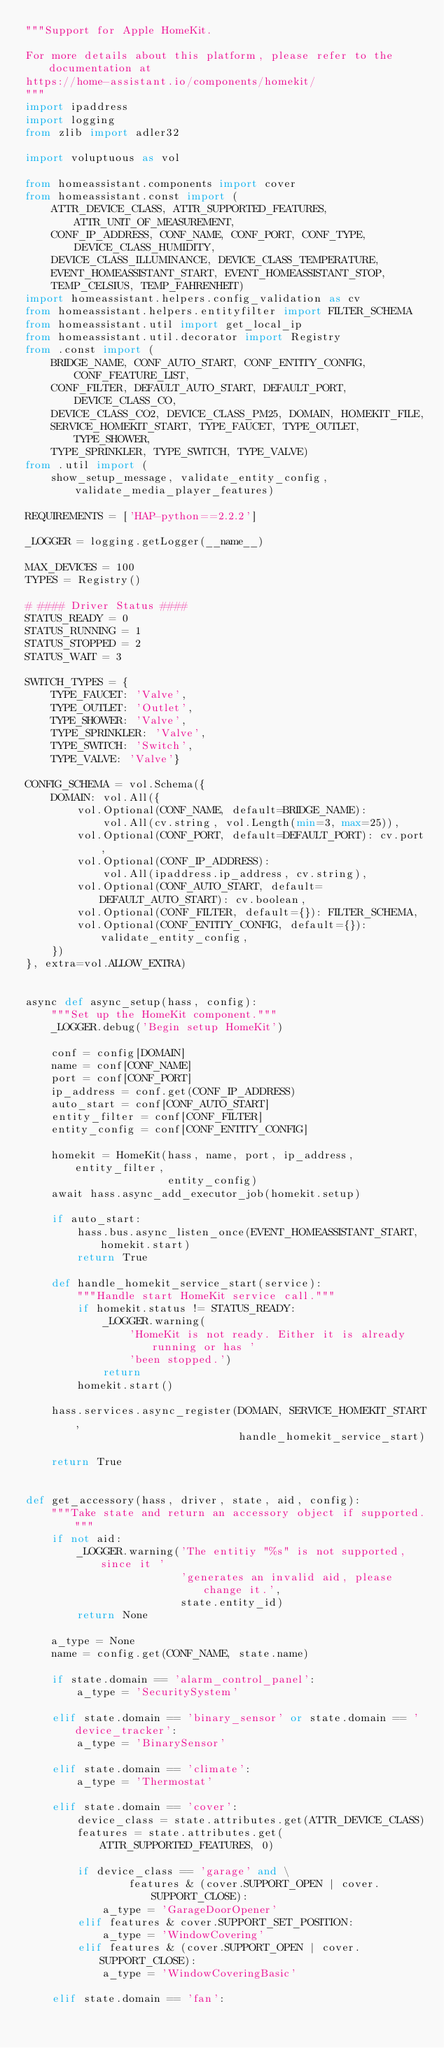Convert code to text. <code><loc_0><loc_0><loc_500><loc_500><_Python_>"""Support for Apple HomeKit.

For more details about this platform, please refer to the documentation at
https://home-assistant.io/components/homekit/
"""
import ipaddress
import logging
from zlib import adler32

import voluptuous as vol

from homeassistant.components import cover
from homeassistant.const import (
    ATTR_DEVICE_CLASS, ATTR_SUPPORTED_FEATURES, ATTR_UNIT_OF_MEASUREMENT,
    CONF_IP_ADDRESS, CONF_NAME, CONF_PORT, CONF_TYPE, DEVICE_CLASS_HUMIDITY,
    DEVICE_CLASS_ILLUMINANCE, DEVICE_CLASS_TEMPERATURE,
    EVENT_HOMEASSISTANT_START, EVENT_HOMEASSISTANT_STOP,
    TEMP_CELSIUS, TEMP_FAHRENHEIT)
import homeassistant.helpers.config_validation as cv
from homeassistant.helpers.entityfilter import FILTER_SCHEMA
from homeassistant.util import get_local_ip
from homeassistant.util.decorator import Registry
from .const import (
    BRIDGE_NAME, CONF_AUTO_START, CONF_ENTITY_CONFIG, CONF_FEATURE_LIST,
    CONF_FILTER, DEFAULT_AUTO_START, DEFAULT_PORT, DEVICE_CLASS_CO,
    DEVICE_CLASS_CO2, DEVICE_CLASS_PM25, DOMAIN, HOMEKIT_FILE,
    SERVICE_HOMEKIT_START, TYPE_FAUCET, TYPE_OUTLET, TYPE_SHOWER,
    TYPE_SPRINKLER, TYPE_SWITCH, TYPE_VALVE)
from .util import (
    show_setup_message, validate_entity_config, validate_media_player_features)

REQUIREMENTS = ['HAP-python==2.2.2']

_LOGGER = logging.getLogger(__name__)

MAX_DEVICES = 100
TYPES = Registry()

# #### Driver Status ####
STATUS_READY = 0
STATUS_RUNNING = 1
STATUS_STOPPED = 2
STATUS_WAIT = 3

SWITCH_TYPES = {
    TYPE_FAUCET: 'Valve',
    TYPE_OUTLET: 'Outlet',
    TYPE_SHOWER: 'Valve',
    TYPE_SPRINKLER: 'Valve',
    TYPE_SWITCH: 'Switch',
    TYPE_VALVE: 'Valve'}

CONFIG_SCHEMA = vol.Schema({
    DOMAIN: vol.All({
        vol.Optional(CONF_NAME, default=BRIDGE_NAME):
            vol.All(cv.string, vol.Length(min=3, max=25)),
        vol.Optional(CONF_PORT, default=DEFAULT_PORT): cv.port,
        vol.Optional(CONF_IP_ADDRESS):
            vol.All(ipaddress.ip_address, cv.string),
        vol.Optional(CONF_AUTO_START, default=DEFAULT_AUTO_START): cv.boolean,
        vol.Optional(CONF_FILTER, default={}): FILTER_SCHEMA,
        vol.Optional(CONF_ENTITY_CONFIG, default={}): validate_entity_config,
    })
}, extra=vol.ALLOW_EXTRA)


async def async_setup(hass, config):
    """Set up the HomeKit component."""
    _LOGGER.debug('Begin setup HomeKit')

    conf = config[DOMAIN]
    name = conf[CONF_NAME]
    port = conf[CONF_PORT]
    ip_address = conf.get(CONF_IP_ADDRESS)
    auto_start = conf[CONF_AUTO_START]
    entity_filter = conf[CONF_FILTER]
    entity_config = conf[CONF_ENTITY_CONFIG]

    homekit = HomeKit(hass, name, port, ip_address, entity_filter,
                      entity_config)
    await hass.async_add_executor_job(homekit.setup)

    if auto_start:
        hass.bus.async_listen_once(EVENT_HOMEASSISTANT_START, homekit.start)
        return True

    def handle_homekit_service_start(service):
        """Handle start HomeKit service call."""
        if homekit.status != STATUS_READY:
            _LOGGER.warning(
                'HomeKit is not ready. Either it is already running or has '
                'been stopped.')
            return
        homekit.start()

    hass.services.async_register(DOMAIN, SERVICE_HOMEKIT_START,
                                 handle_homekit_service_start)

    return True


def get_accessory(hass, driver, state, aid, config):
    """Take state and return an accessory object if supported."""
    if not aid:
        _LOGGER.warning('The entitiy "%s" is not supported, since it '
                        'generates an invalid aid, please change it.',
                        state.entity_id)
        return None

    a_type = None
    name = config.get(CONF_NAME, state.name)

    if state.domain == 'alarm_control_panel':
        a_type = 'SecuritySystem'

    elif state.domain == 'binary_sensor' or state.domain == 'device_tracker':
        a_type = 'BinarySensor'

    elif state.domain == 'climate':
        a_type = 'Thermostat'

    elif state.domain == 'cover':
        device_class = state.attributes.get(ATTR_DEVICE_CLASS)
        features = state.attributes.get(ATTR_SUPPORTED_FEATURES, 0)

        if device_class == 'garage' and \
                features & (cover.SUPPORT_OPEN | cover.SUPPORT_CLOSE):
            a_type = 'GarageDoorOpener'
        elif features & cover.SUPPORT_SET_POSITION:
            a_type = 'WindowCovering'
        elif features & (cover.SUPPORT_OPEN | cover.SUPPORT_CLOSE):
            a_type = 'WindowCoveringBasic'

    elif state.domain == 'fan':</code> 